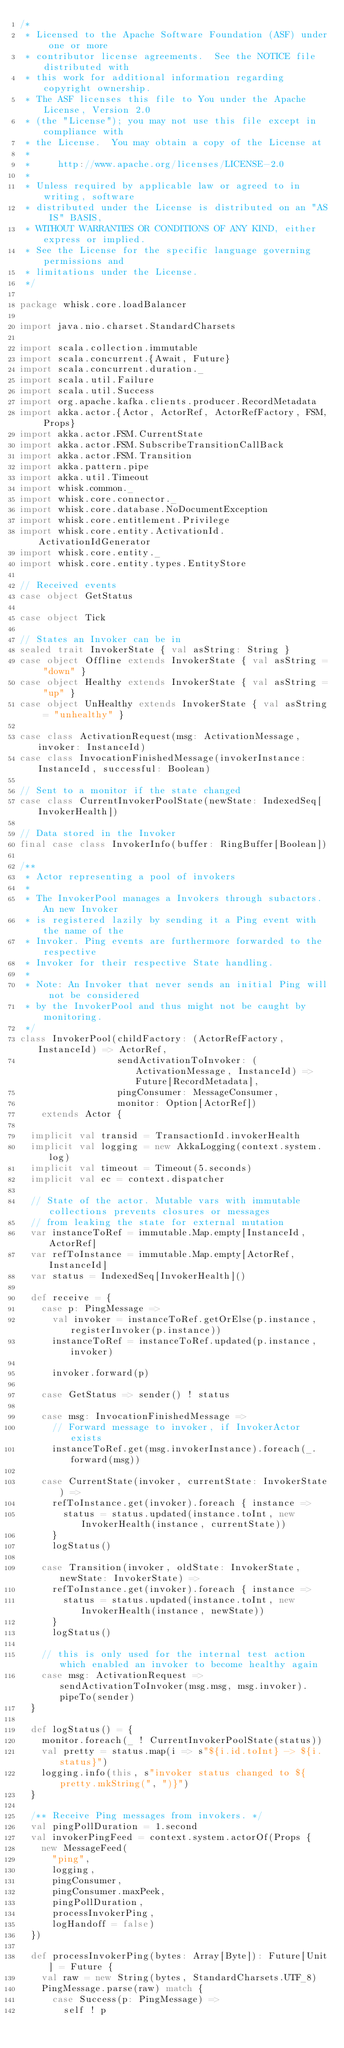Convert code to text. <code><loc_0><loc_0><loc_500><loc_500><_Scala_>/*
 * Licensed to the Apache Software Foundation (ASF) under one or more
 * contributor license agreements.  See the NOTICE file distributed with
 * this work for additional information regarding copyright ownership.
 * The ASF licenses this file to You under the Apache License, Version 2.0
 * (the "License"); you may not use this file except in compliance with
 * the License.  You may obtain a copy of the License at
 *
 *     http://www.apache.org/licenses/LICENSE-2.0
 *
 * Unless required by applicable law or agreed to in writing, software
 * distributed under the License is distributed on an "AS IS" BASIS,
 * WITHOUT WARRANTIES OR CONDITIONS OF ANY KIND, either express or implied.
 * See the License for the specific language governing permissions and
 * limitations under the License.
 */

package whisk.core.loadBalancer

import java.nio.charset.StandardCharsets

import scala.collection.immutable
import scala.concurrent.{Await, Future}
import scala.concurrent.duration._
import scala.util.Failure
import scala.util.Success
import org.apache.kafka.clients.producer.RecordMetadata
import akka.actor.{Actor, ActorRef, ActorRefFactory, FSM, Props}
import akka.actor.FSM.CurrentState
import akka.actor.FSM.SubscribeTransitionCallBack
import akka.actor.FSM.Transition
import akka.pattern.pipe
import akka.util.Timeout
import whisk.common._
import whisk.core.connector._
import whisk.core.database.NoDocumentException
import whisk.core.entitlement.Privilege
import whisk.core.entity.ActivationId.ActivationIdGenerator
import whisk.core.entity._
import whisk.core.entity.types.EntityStore

// Received events
case object GetStatus

case object Tick

// States an Invoker can be in
sealed trait InvokerState { val asString: String }
case object Offline extends InvokerState { val asString = "down" }
case object Healthy extends InvokerState { val asString = "up" }
case object UnHealthy extends InvokerState { val asString = "unhealthy" }

case class ActivationRequest(msg: ActivationMessage, invoker: InstanceId)
case class InvocationFinishedMessage(invokerInstance: InstanceId, successful: Boolean)

// Sent to a monitor if the state changed
case class CurrentInvokerPoolState(newState: IndexedSeq[InvokerHealth])

// Data stored in the Invoker
final case class InvokerInfo(buffer: RingBuffer[Boolean])

/**
 * Actor representing a pool of invokers
 *
 * The InvokerPool manages a Invokers through subactors. An new Invoker
 * is registered lazily by sending it a Ping event with the name of the
 * Invoker. Ping events are furthermore forwarded to the respective
 * Invoker for their respective State handling.
 *
 * Note: An Invoker that never sends an initial Ping will not be considered
 * by the InvokerPool and thus might not be caught by monitoring.
 */
class InvokerPool(childFactory: (ActorRefFactory, InstanceId) => ActorRef,
                  sendActivationToInvoker: (ActivationMessage, InstanceId) => Future[RecordMetadata],
                  pingConsumer: MessageConsumer,
                  monitor: Option[ActorRef])
    extends Actor {

  implicit val transid = TransactionId.invokerHealth
  implicit val logging = new AkkaLogging(context.system.log)
  implicit val timeout = Timeout(5.seconds)
  implicit val ec = context.dispatcher

  // State of the actor. Mutable vars with immutable collections prevents closures or messages
  // from leaking the state for external mutation
  var instanceToRef = immutable.Map.empty[InstanceId, ActorRef]
  var refToInstance = immutable.Map.empty[ActorRef, InstanceId]
  var status = IndexedSeq[InvokerHealth]()

  def receive = {
    case p: PingMessage =>
      val invoker = instanceToRef.getOrElse(p.instance, registerInvoker(p.instance))
      instanceToRef = instanceToRef.updated(p.instance, invoker)

      invoker.forward(p)

    case GetStatus => sender() ! status

    case msg: InvocationFinishedMessage =>
      // Forward message to invoker, if InvokerActor exists
      instanceToRef.get(msg.invokerInstance).foreach(_.forward(msg))

    case CurrentState(invoker, currentState: InvokerState) =>
      refToInstance.get(invoker).foreach { instance =>
        status = status.updated(instance.toInt, new InvokerHealth(instance, currentState))
      }
      logStatus()

    case Transition(invoker, oldState: InvokerState, newState: InvokerState) =>
      refToInstance.get(invoker).foreach { instance =>
        status = status.updated(instance.toInt, new InvokerHealth(instance, newState))
      }
      logStatus()

    // this is only used for the internal test action which enabled an invoker to become healthy again
    case msg: ActivationRequest => sendActivationToInvoker(msg.msg, msg.invoker).pipeTo(sender)
  }

  def logStatus() = {
    monitor.foreach(_ ! CurrentInvokerPoolState(status))
    val pretty = status.map(i => s"${i.id.toInt} -> ${i.status}")
    logging.info(this, s"invoker status changed to ${pretty.mkString(", ")}")
  }

  /** Receive Ping messages from invokers. */
  val pingPollDuration = 1.second
  val invokerPingFeed = context.system.actorOf(Props {
    new MessageFeed(
      "ping",
      logging,
      pingConsumer,
      pingConsumer.maxPeek,
      pingPollDuration,
      processInvokerPing,
      logHandoff = false)
  })

  def processInvokerPing(bytes: Array[Byte]): Future[Unit] = Future {
    val raw = new String(bytes, StandardCharsets.UTF_8)
    PingMessage.parse(raw) match {
      case Success(p: PingMessage) =>
        self ! p</code> 